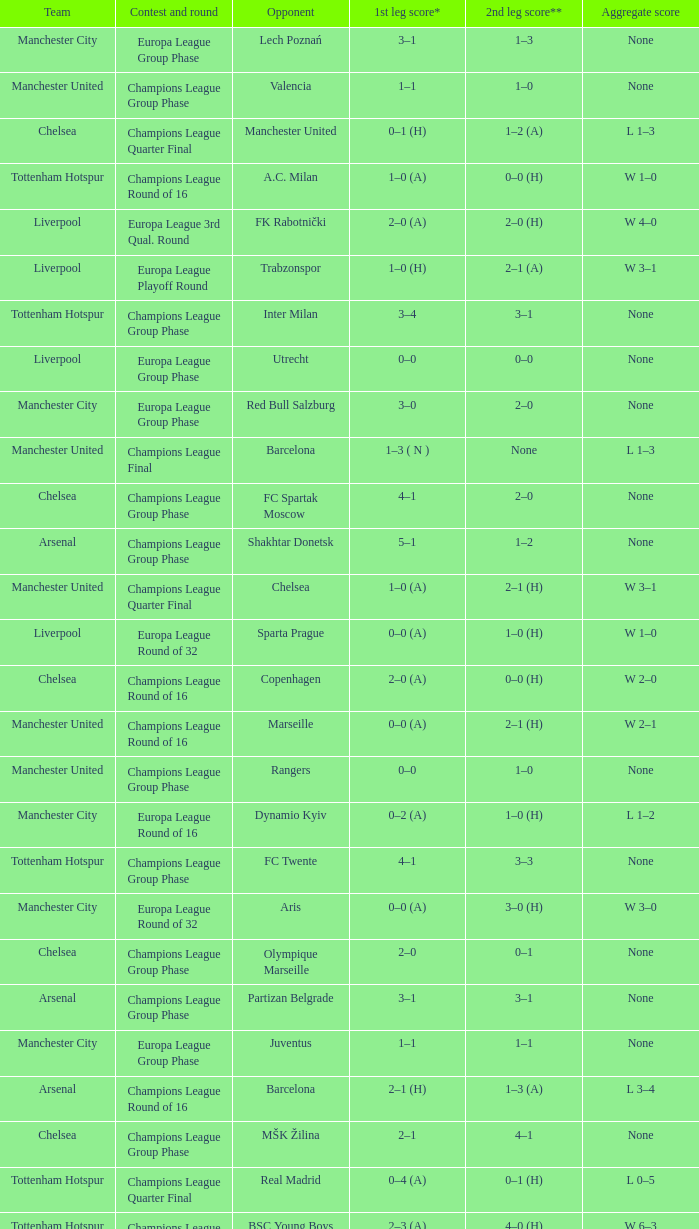How many goals did each one of the teams score in the first leg of the match between Liverpool and Trabzonspor? 1–0 (H). 